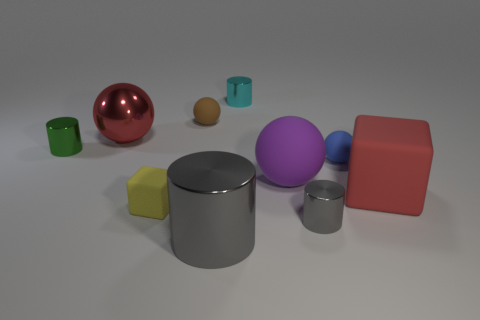Subtract all large gray cylinders. How many cylinders are left? 3 Subtract all red spheres. How many gray cylinders are left? 2 Subtract all green cylinders. How many cylinders are left? 3 Subtract all blocks. How many objects are left? 8 Subtract 1 yellow cubes. How many objects are left? 9 Subtract 1 blocks. How many blocks are left? 1 Subtract all green cubes. Subtract all blue balls. How many cubes are left? 2 Subtract all tiny cyan things. Subtract all small objects. How many objects are left? 3 Add 3 cylinders. How many cylinders are left? 7 Add 5 red spheres. How many red spheres exist? 6 